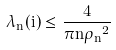Convert formula to latex. <formula><loc_0><loc_0><loc_500><loc_500>\lambda _ { n } ( i ) \leq \frac { 4 } { \pi n { \rho _ { n } } ^ { 2 } }</formula> 